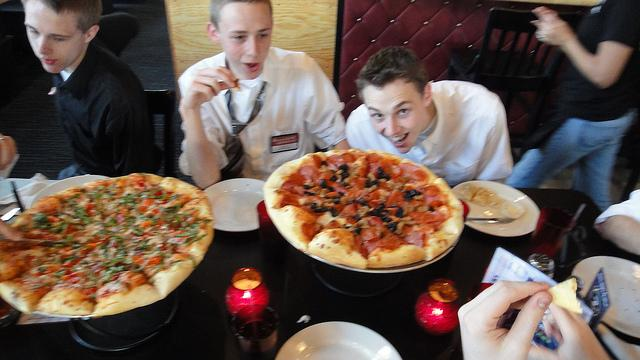What setting is the outfit of the boy sitting in the middle usually found?

Choices:
A) pool
B) car race
C) horse race
D) office office 